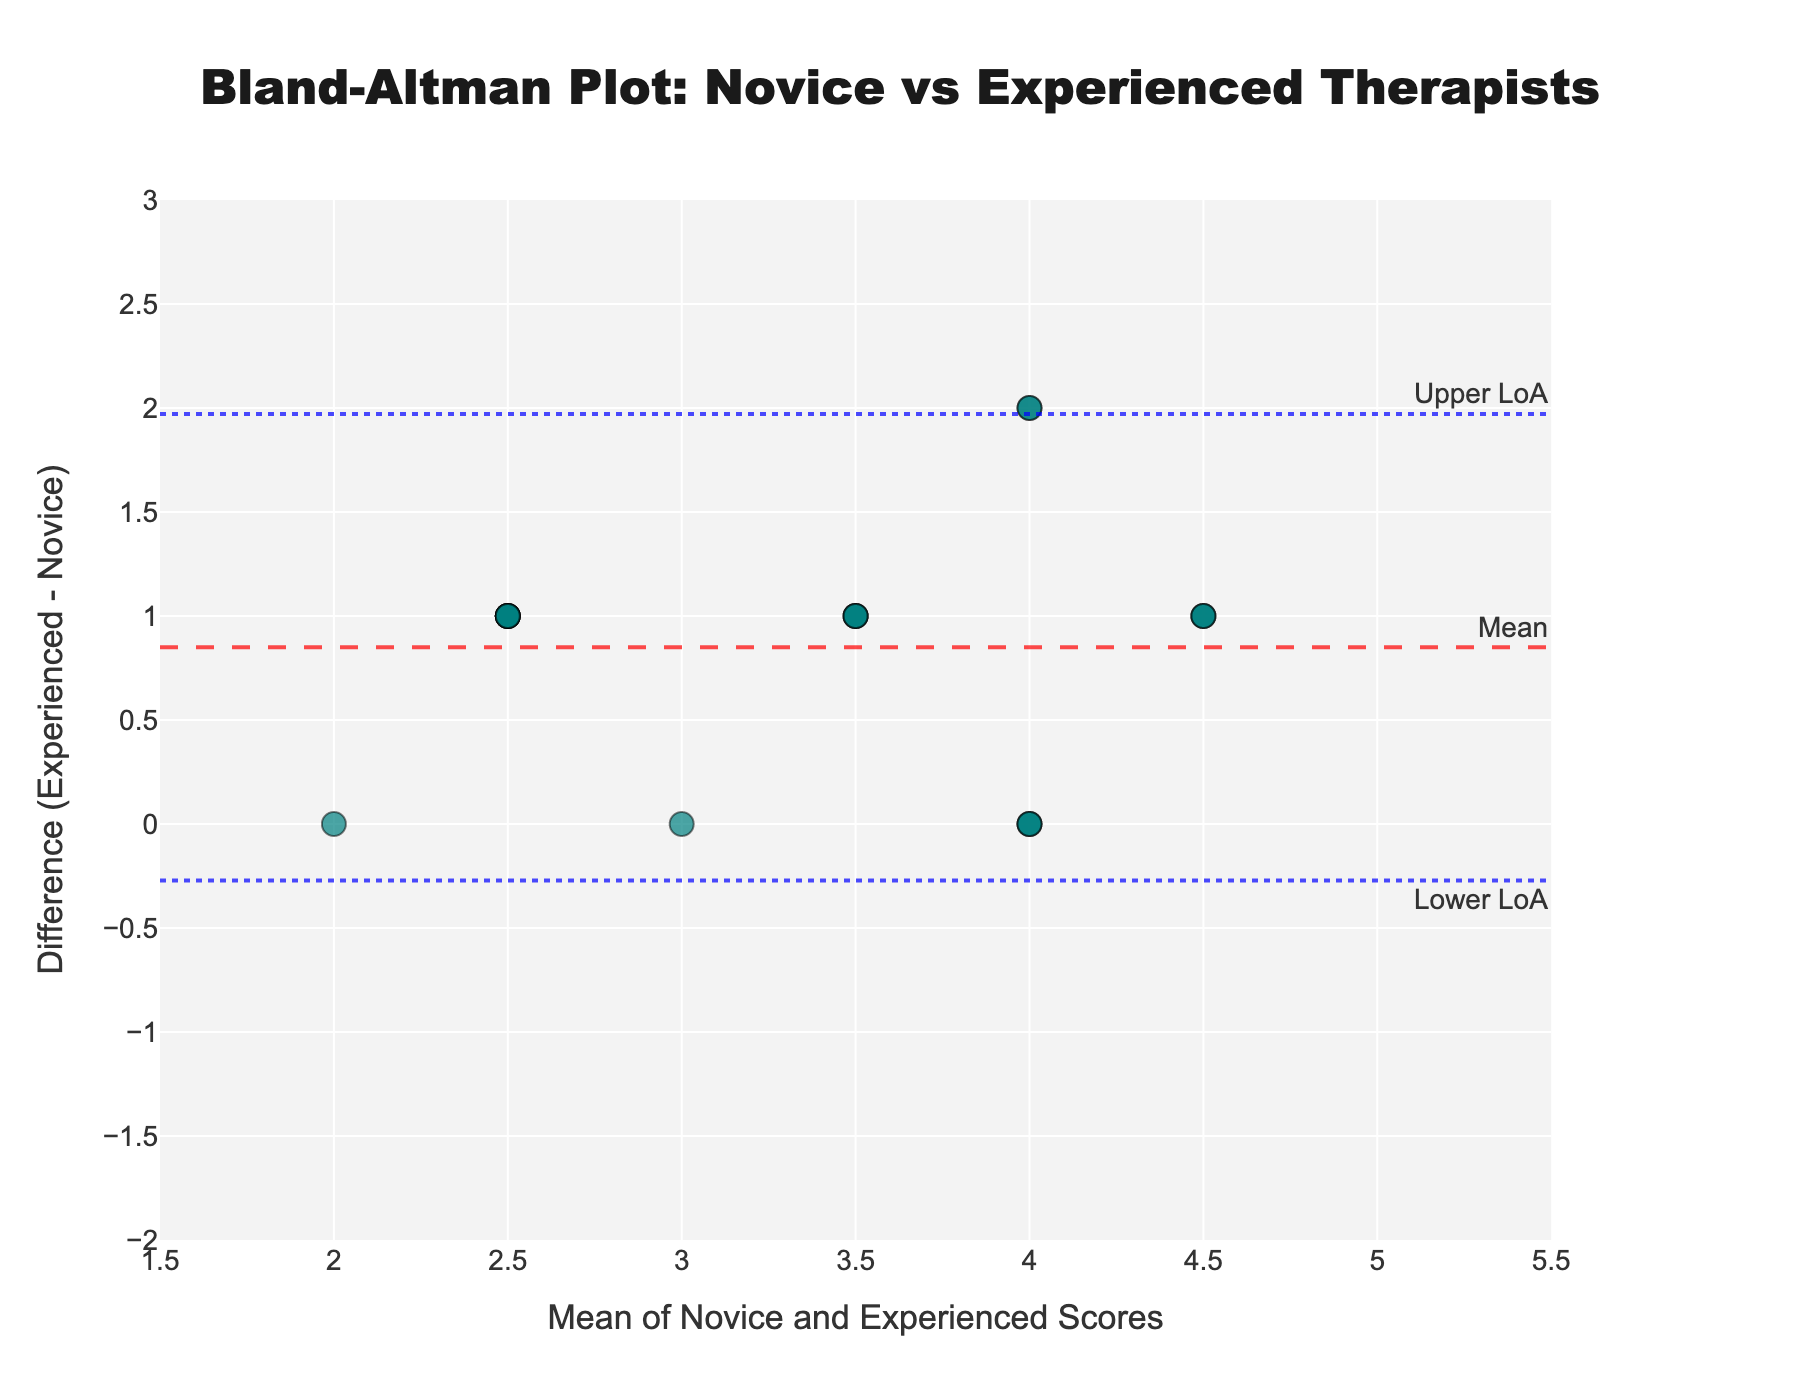What's the title of the plot? The title is displayed at the top of the plot and describes what the Bland-Altman plot is about.
Answer: Bland-Altman Plot: Novice vs Experienced Therapists What is the y-axis label? The y-axis label indicates what the y-values represent in the plot.
Answer: Difference (Experienced - Novice) What is the x-axis label? The x-axis label indicates what the x-values represent in the plot.
Answer: Mean of Novice and Experienced Scores What is the color of the data points on the plot? The description of the markers indicates they are in a translucent teal color.
Answer: Teal What are the limits of agreement in this plot? The upper and lower limits are where the horizontal dashed and dotted lines are placed. The upper limit of agreement is 1.19, and the lower limit of agreement is -0.79.
Answer: Upper: 1.19, Lower: -0.79 How many data points lie above the mean difference line? Count the number of data points shown above the horizontal dashed red line indicating the mean difference. Out of 20 data points, 11 are above the mean difference line.
Answer: 11 What is the mean difference between novice and experienced scores? The mean difference is indicated by the dashed horizontal line near the center of the plot. From the annotations, this value is around 0.20.
Answer: 0.20 Which therapist's scores showed the greatest positive difference between novice and experienced measurements? Identify the data point with the highest value on the y-axis. David Rodriguez's difference score is 2, which is the highest positive difference.
Answer: David Rodriguez How consistent are the measurements between novice and experienced therapists around a mean score of 3.5? Look for points around the mean score of 3.5 on the x-axis and examine their distance from the mean difference line. The points are dispersed but mostly clustered around the mean difference.
Answer: Moderately consistent Are there any data points below the lower limit of agreement? Examine the plot for any data points below the lower dotted blue line. No data points are below the lower limit of agreement.
Answer: No 